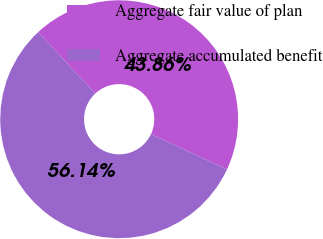Convert chart to OTSL. <chart><loc_0><loc_0><loc_500><loc_500><pie_chart><fcel>Aggregate fair value of plan<fcel>Aggregate accumulated benefit<nl><fcel>43.86%<fcel>56.14%<nl></chart> 